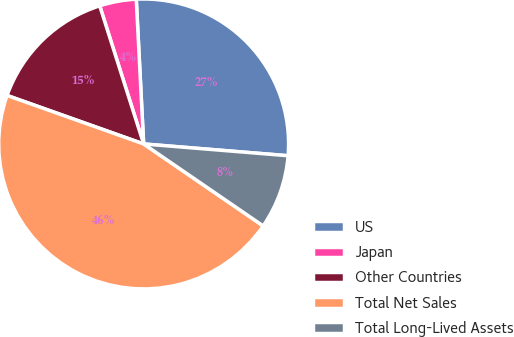Convert chart to OTSL. <chart><loc_0><loc_0><loc_500><loc_500><pie_chart><fcel>US<fcel>Japan<fcel>Other Countries<fcel>Total Net Sales<fcel>Total Long-Lived Assets<nl><fcel>27.11%<fcel>4.09%<fcel>14.67%<fcel>45.87%<fcel>8.27%<nl></chart> 